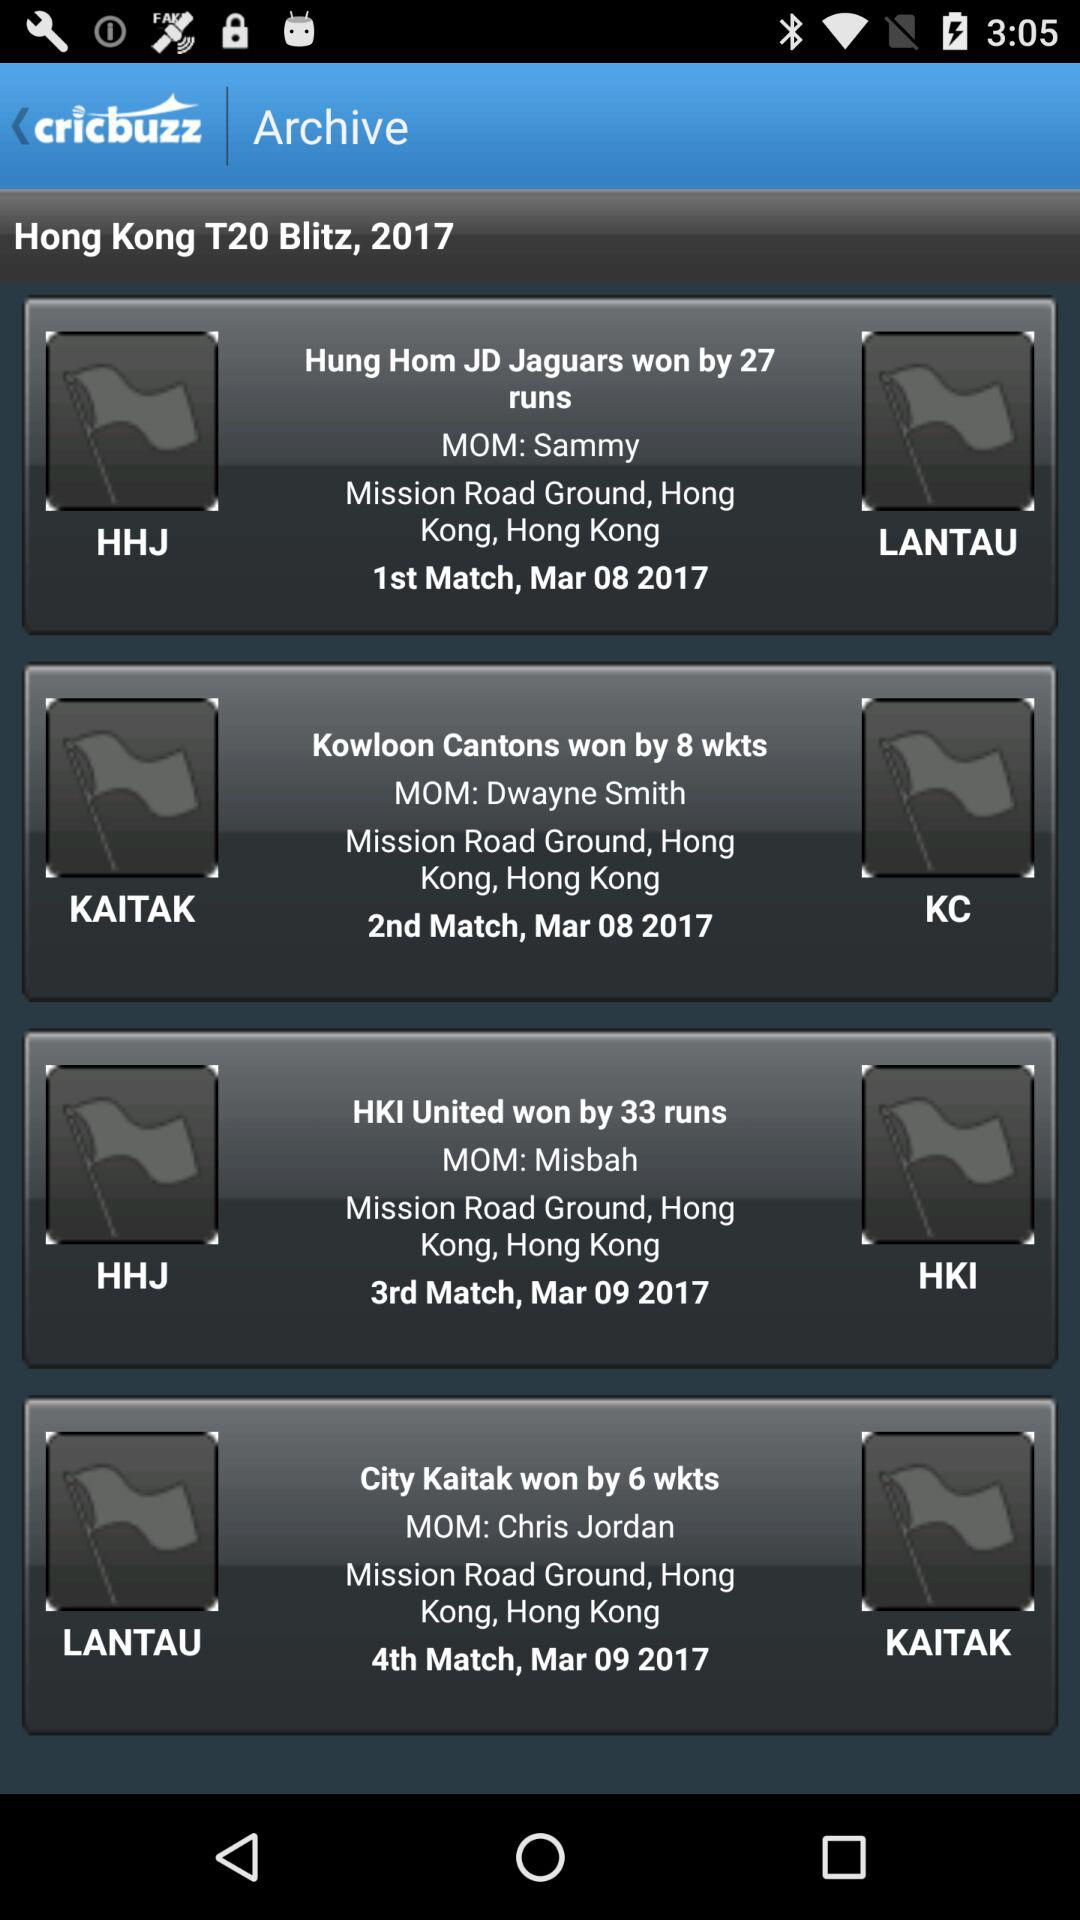How many runs did "HKI United" win by? "HKI United" won by 33 runs. 